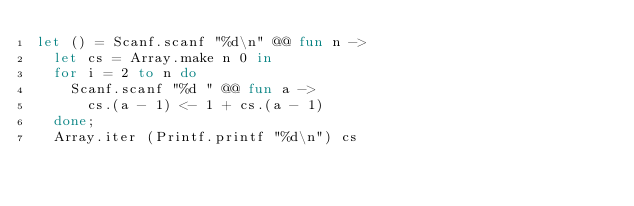Convert code to text. <code><loc_0><loc_0><loc_500><loc_500><_OCaml_>let () = Scanf.scanf "%d\n" @@ fun n ->
  let cs = Array.make n 0 in
  for i = 2 to n do
    Scanf.scanf "%d " @@ fun a ->
      cs.(a - 1) <- 1 + cs.(a - 1)
  done;
  Array.iter (Printf.printf "%d\n") cs
</code> 